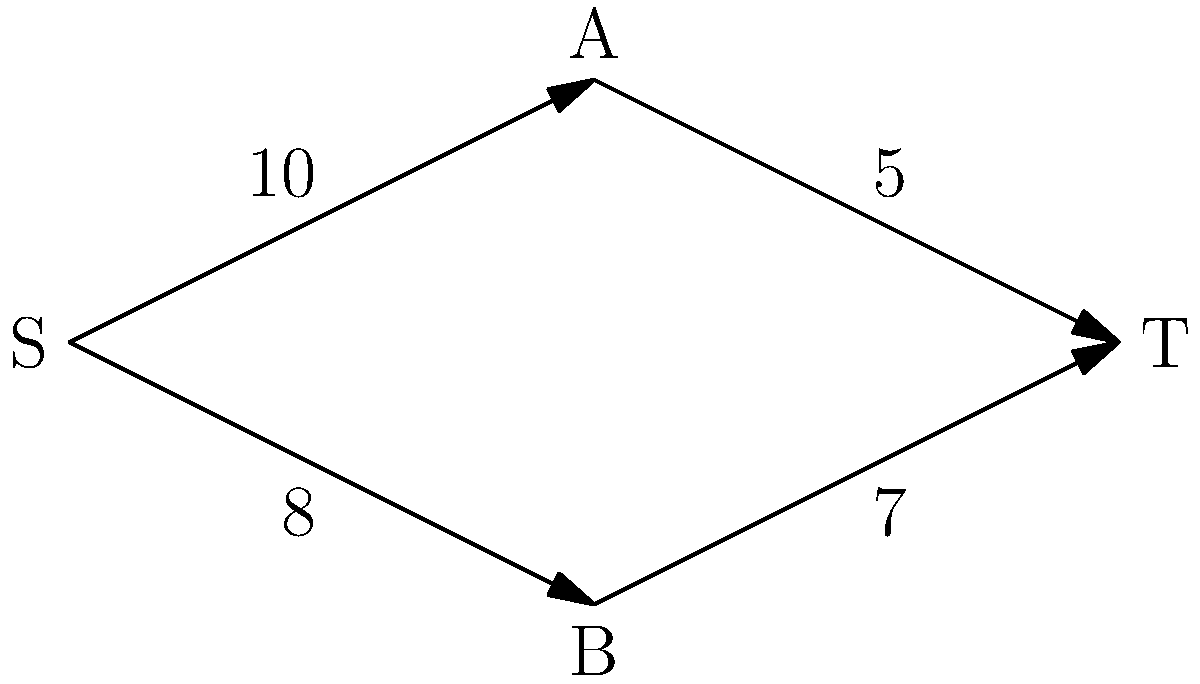As a proud parent of a Science Leadership Academy student, you're helping your child understand network flow problems. Given the directed graph above representing a network with source S and sink T, what is the maximum flow from S to T? Assume each edge is labeled with its capacity. Let's solve this step-by-step using the Ford-Fulkerson algorithm:

1) Start with zero flow on all edges.

2) Find an augmenting path from S to T:
   S → A → T (min capacity = 5)
   Increase flow by 5.

3) Update residual graph:
   S → A: 10 - 5 = 5
   A → T: 5 - 5 = 0
   T → A: 0 + 5 = 5 (backward edge)

4) Find another augmenting path:
   S → B → T (min capacity = 7)
   Increase flow by 7.

5) Update residual graph:
   S → B: 8 - 7 = 1
   B → T: 7 - 7 = 0
   T → B: 0 + 7 = 7 (backward edge)

6) Find another augmenting path:
   S → A → B → T (min capacity = 1)
   Increase flow by 1.

7) Update residual graph:
   S → A: 5 - 1 = 4
   A → B: ∞ - 1 = ∞ (this edge wasn't in original graph)
   B → T: 0 + 1 = 1

8) No more augmenting paths exist.

The maximum flow is the sum of all flow increases: 5 + 7 + 1 = 13.
Answer: 13 